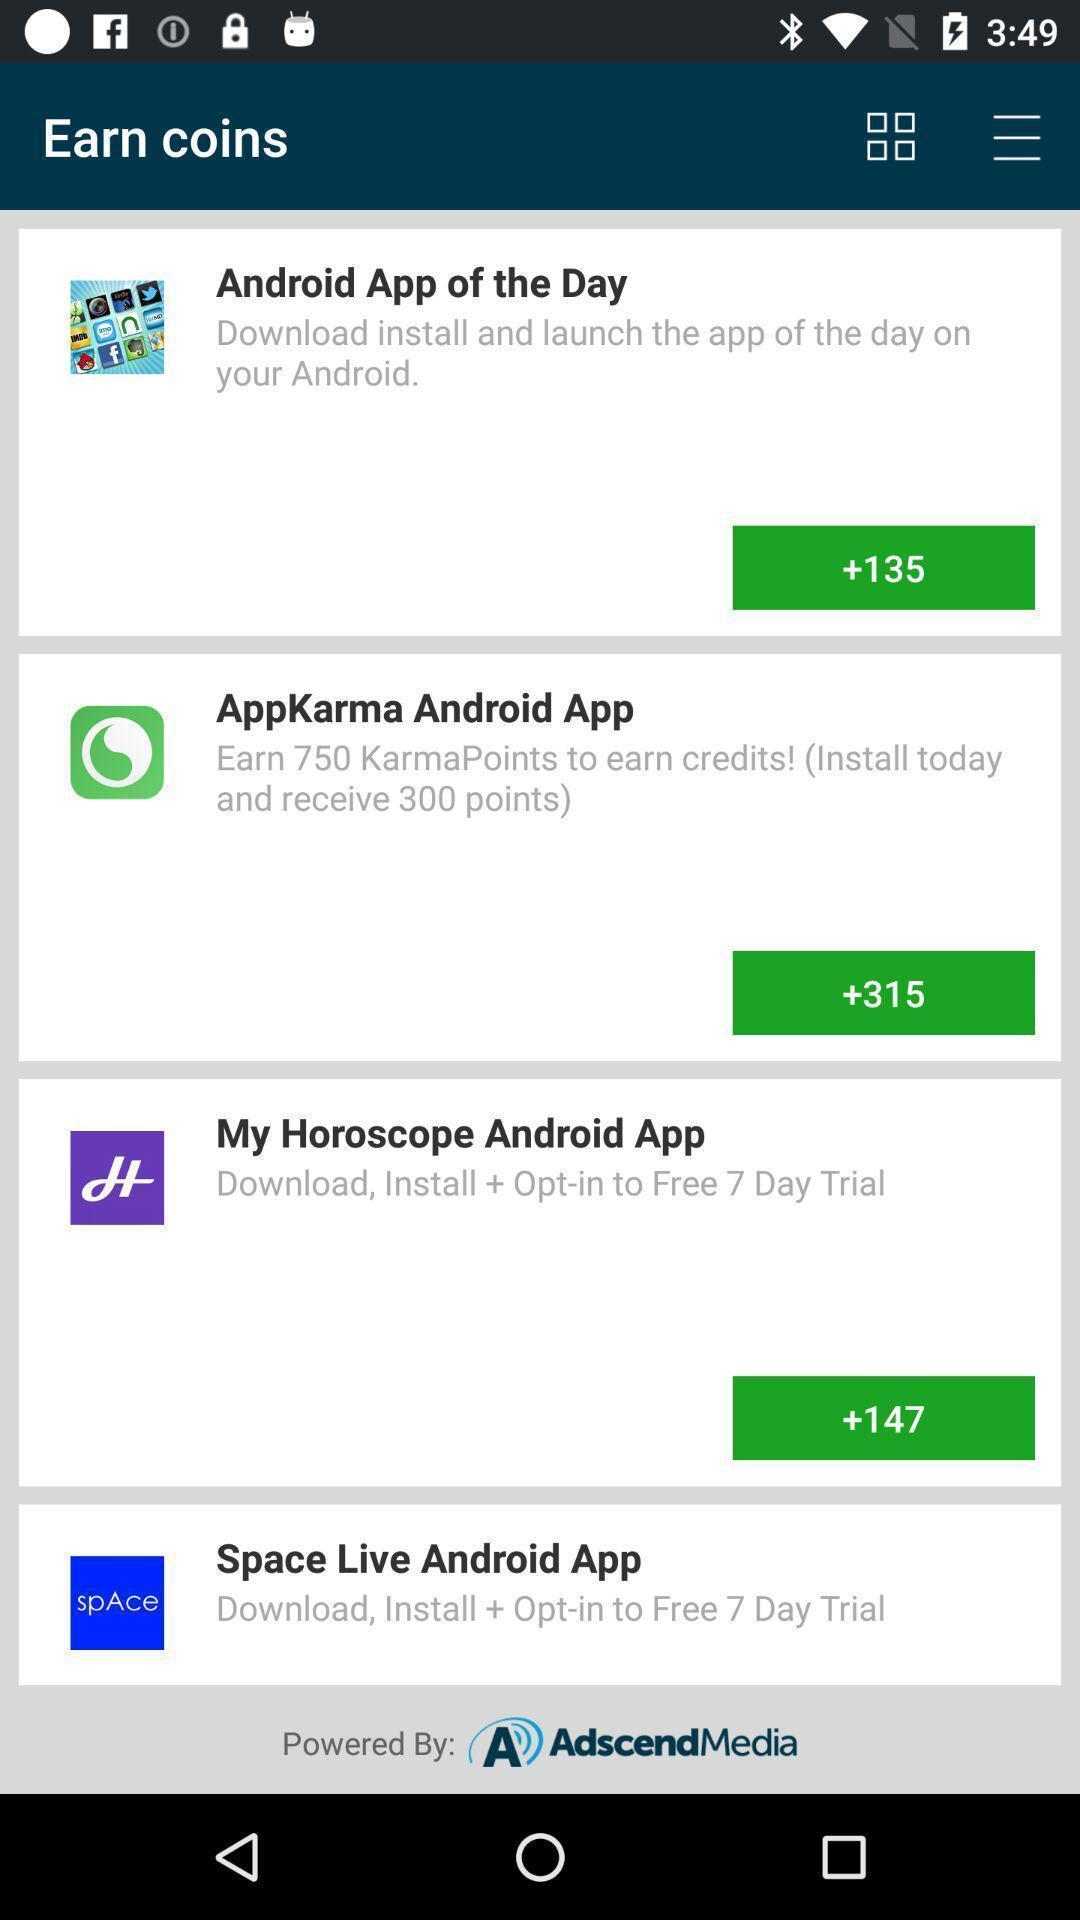What can you discern from this picture? Screen showing earn coins. 